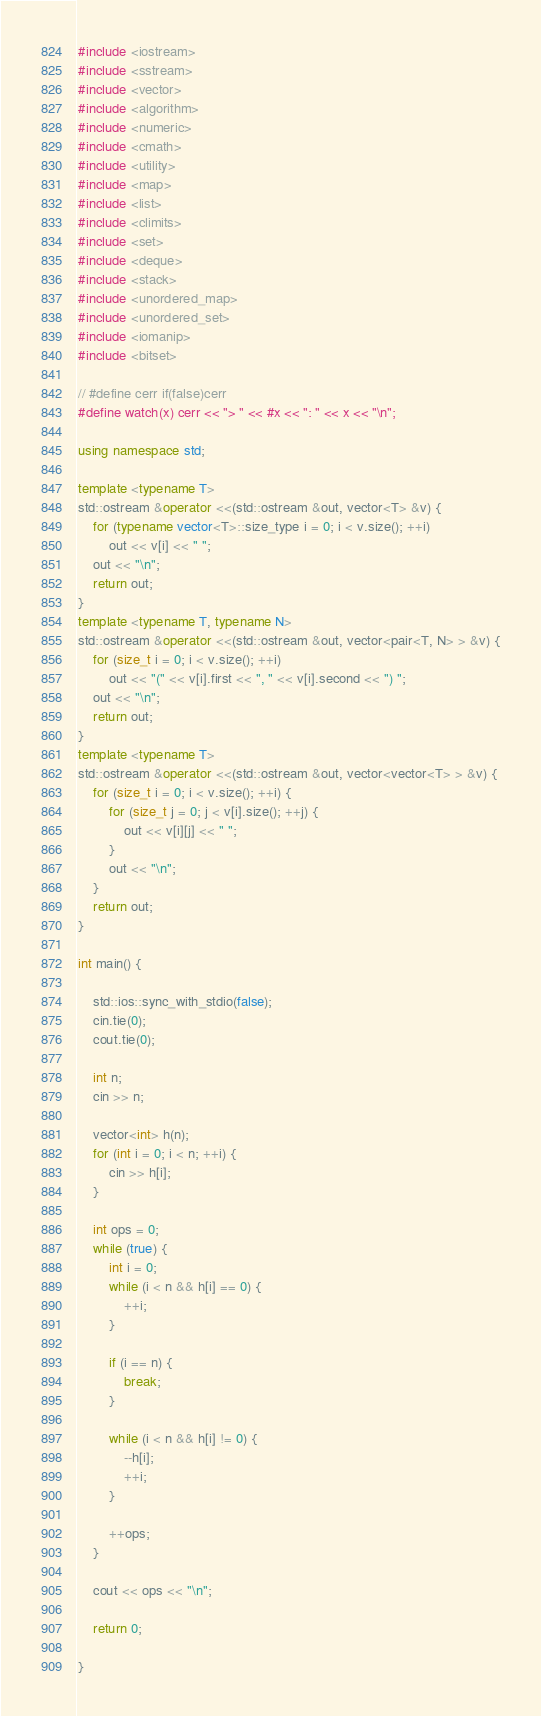Convert code to text. <code><loc_0><loc_0><loc_500><loc_500><_C++_>#include <iostream>
#include <sstream>
#include <vector>
#include <algorithm>
#include <numeric>
#include <cmath>
#include <utility>
#include <map>
#include <list>
#include <climits>
#include <set>
#include <deque>
#include <stack>
#include <unordered_map>
#include <unordered_set>
#include <iomanip>
#include <bitset>

// #define cerr if(false)cerr
#define watch(x) cerr << "> " << #x << ": " << x << "\n";

using namespace std;

template <typename T>
std::ostream &operator <<(std::ostream &out, vector<T> &v) {
	for (typename vector<T>::size_type i = 0; i < v.size(); ++i)
		out << v[i] << " ";
	out << "\n";
    return out;
}
template <typename T, typename N>
std::ostream &operator <<(std::ostream &out, vector<pair<T, N> > &v) {
	for (size_t i = 0; i < v.size(); ++i)
		out << "(" << v[i].first << ", " << v[i].second << ") ";
	out << "\n";
    return out;
}
template <typename T>
std::ostream &operator <<(std::ostream &out, vector<vector<T> > &v) {
	for (size_t i = 0; i < v.size(); ++i) {
		for (size_t j = 0; j < v[i].size(); ++j) {
			out << v[i][j] << " ";
		}
		out << "\n";
	}
   	return out;
}

int main() {

	std::ios::sync_with_stdio(false);
	cin.tie(0);
	cout.tie(0);

	int n;
	cin >> n;

	vector<int> h(n);
	for (int i = 0; i < n; ++i) {
		cin >> h[i];
	}

	int ops = 0;
	while (true) {
		int i = 0; 
		while (i < n && h[i] == 0) {
			++i;
		}

		if (i == n) {
			break;
		}

		while (i < n && h[i] != 0) {
			--h[i];
			++i;
		}

		++ops;
	}

	cout << ops << "\n";

	return 0;

}</code> 